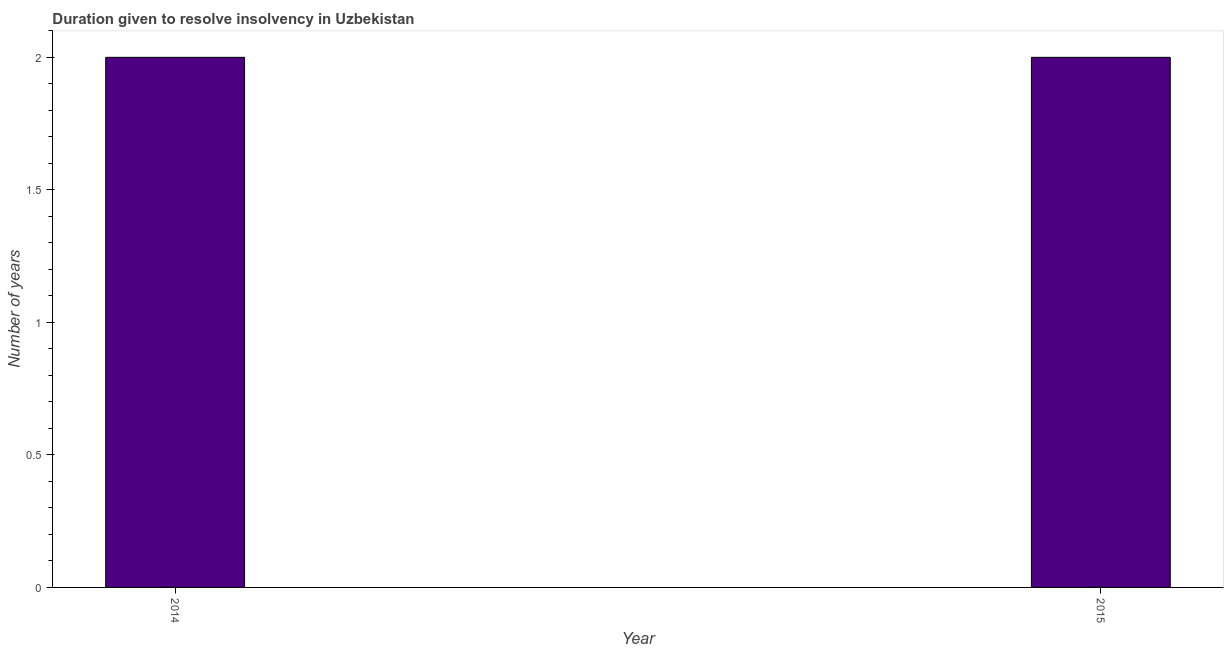What is the title of the graph?
Ensure brevity in your answer.  Duration given to resolve insolvency in Uzbekistan. What is the label or title of the Y-axis?
Provide a succinct answer. Number of years. What is the number of years to resolve insolvency in 2015?
Your response must be concise. 2. In which year was the number of years to resolve insolvency maximum?
Keep it short and to the point. 2014. In which year was the number of years to resolve insolvency minimum?
Your answer should be compact. 2014. What is the difference between the number of years to resolve insolvency in 2014 and 2015?
Provide a succinct answer. 0. What is the median number of years to resolve insolvency?
Keep it short and to the point. 2. Do a majority of the years between 2015 and 2014 (inclusive) have number of years to resolve insolvency greater than 1.9 ?
Make the answer very short. No. Are all the bars in the graph horizontal?
Provide a short and direct response. No. What is the Number of years in 2014?
Keep it short and to the point. 2. 